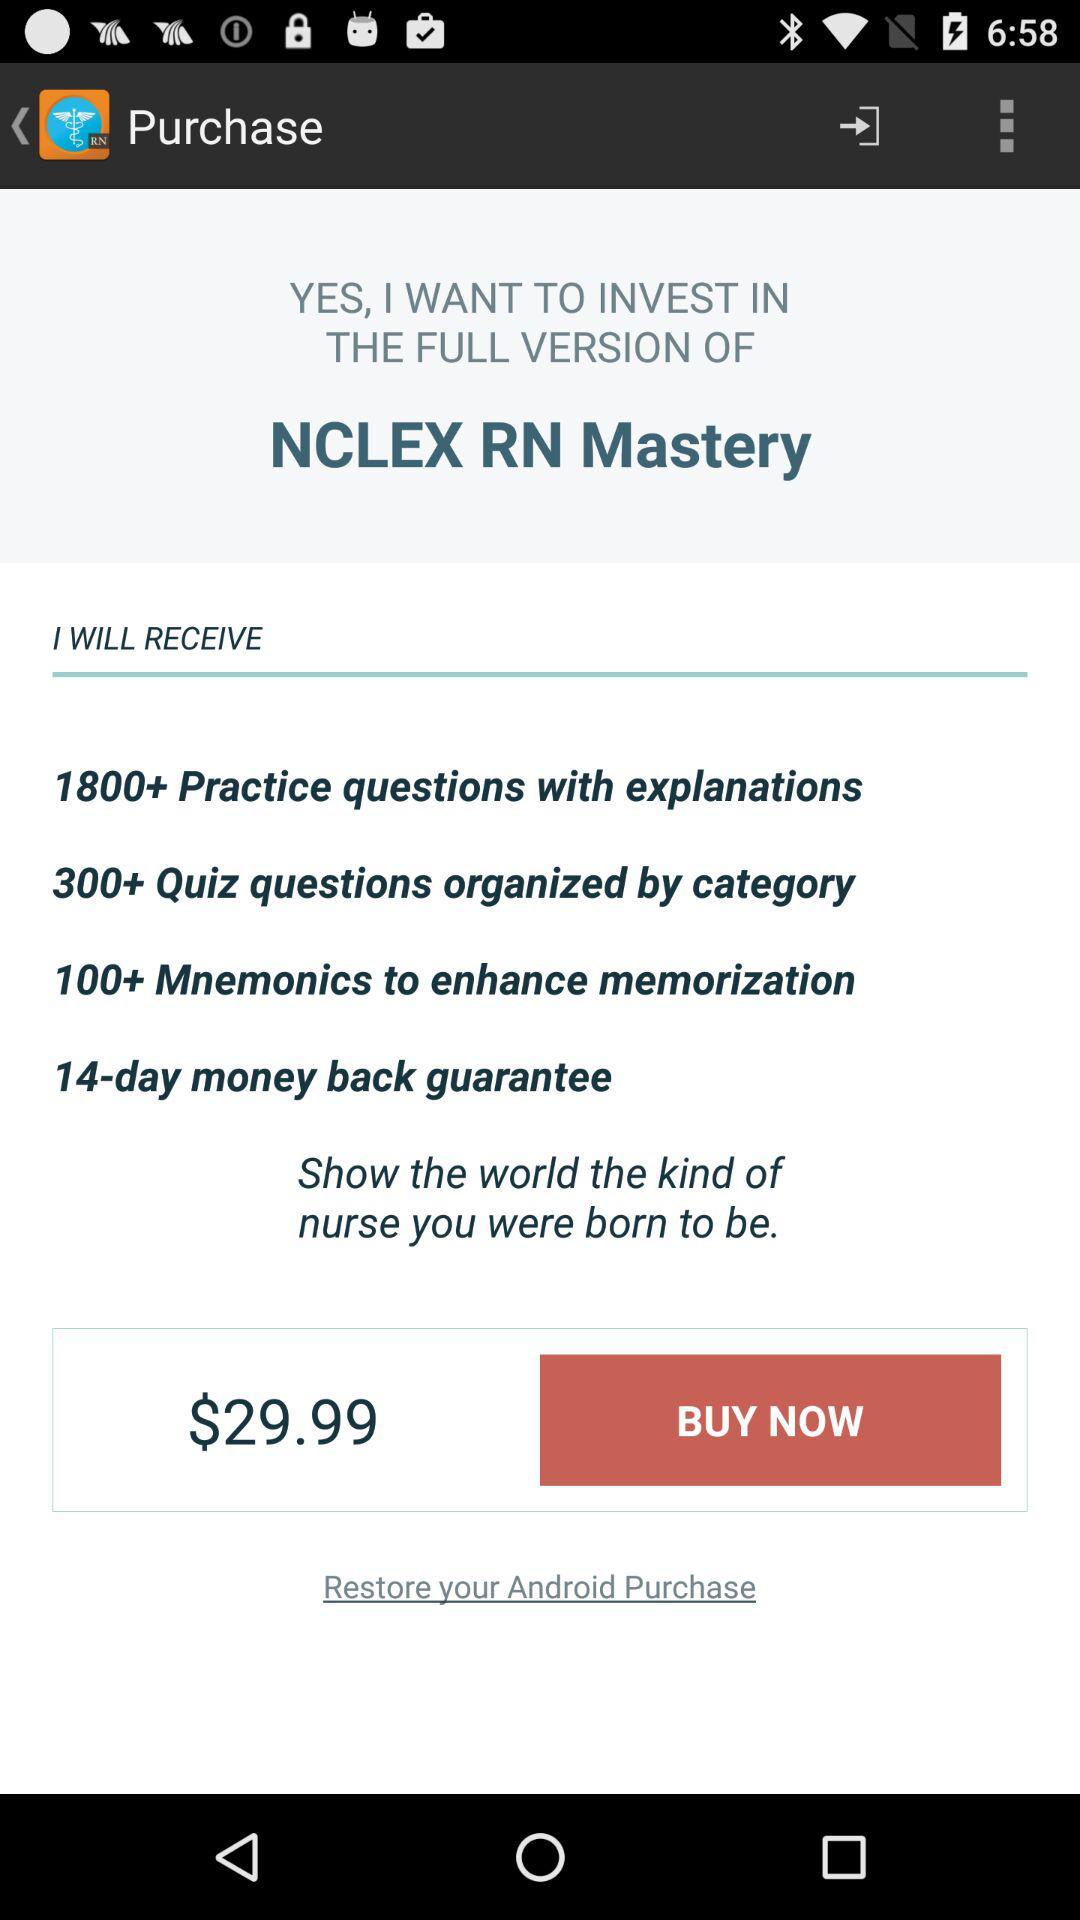What will we get after purchasing the full version of "NCLEX RN Mastery"? You will get "1800+ Practice questions with explanations", "300+ Quiz questions organized by category", "100+ Mnemonics to enhance memorization" and "14-day money back guarantee" after purchasing the full version of "NCLEX RN Mastery". 